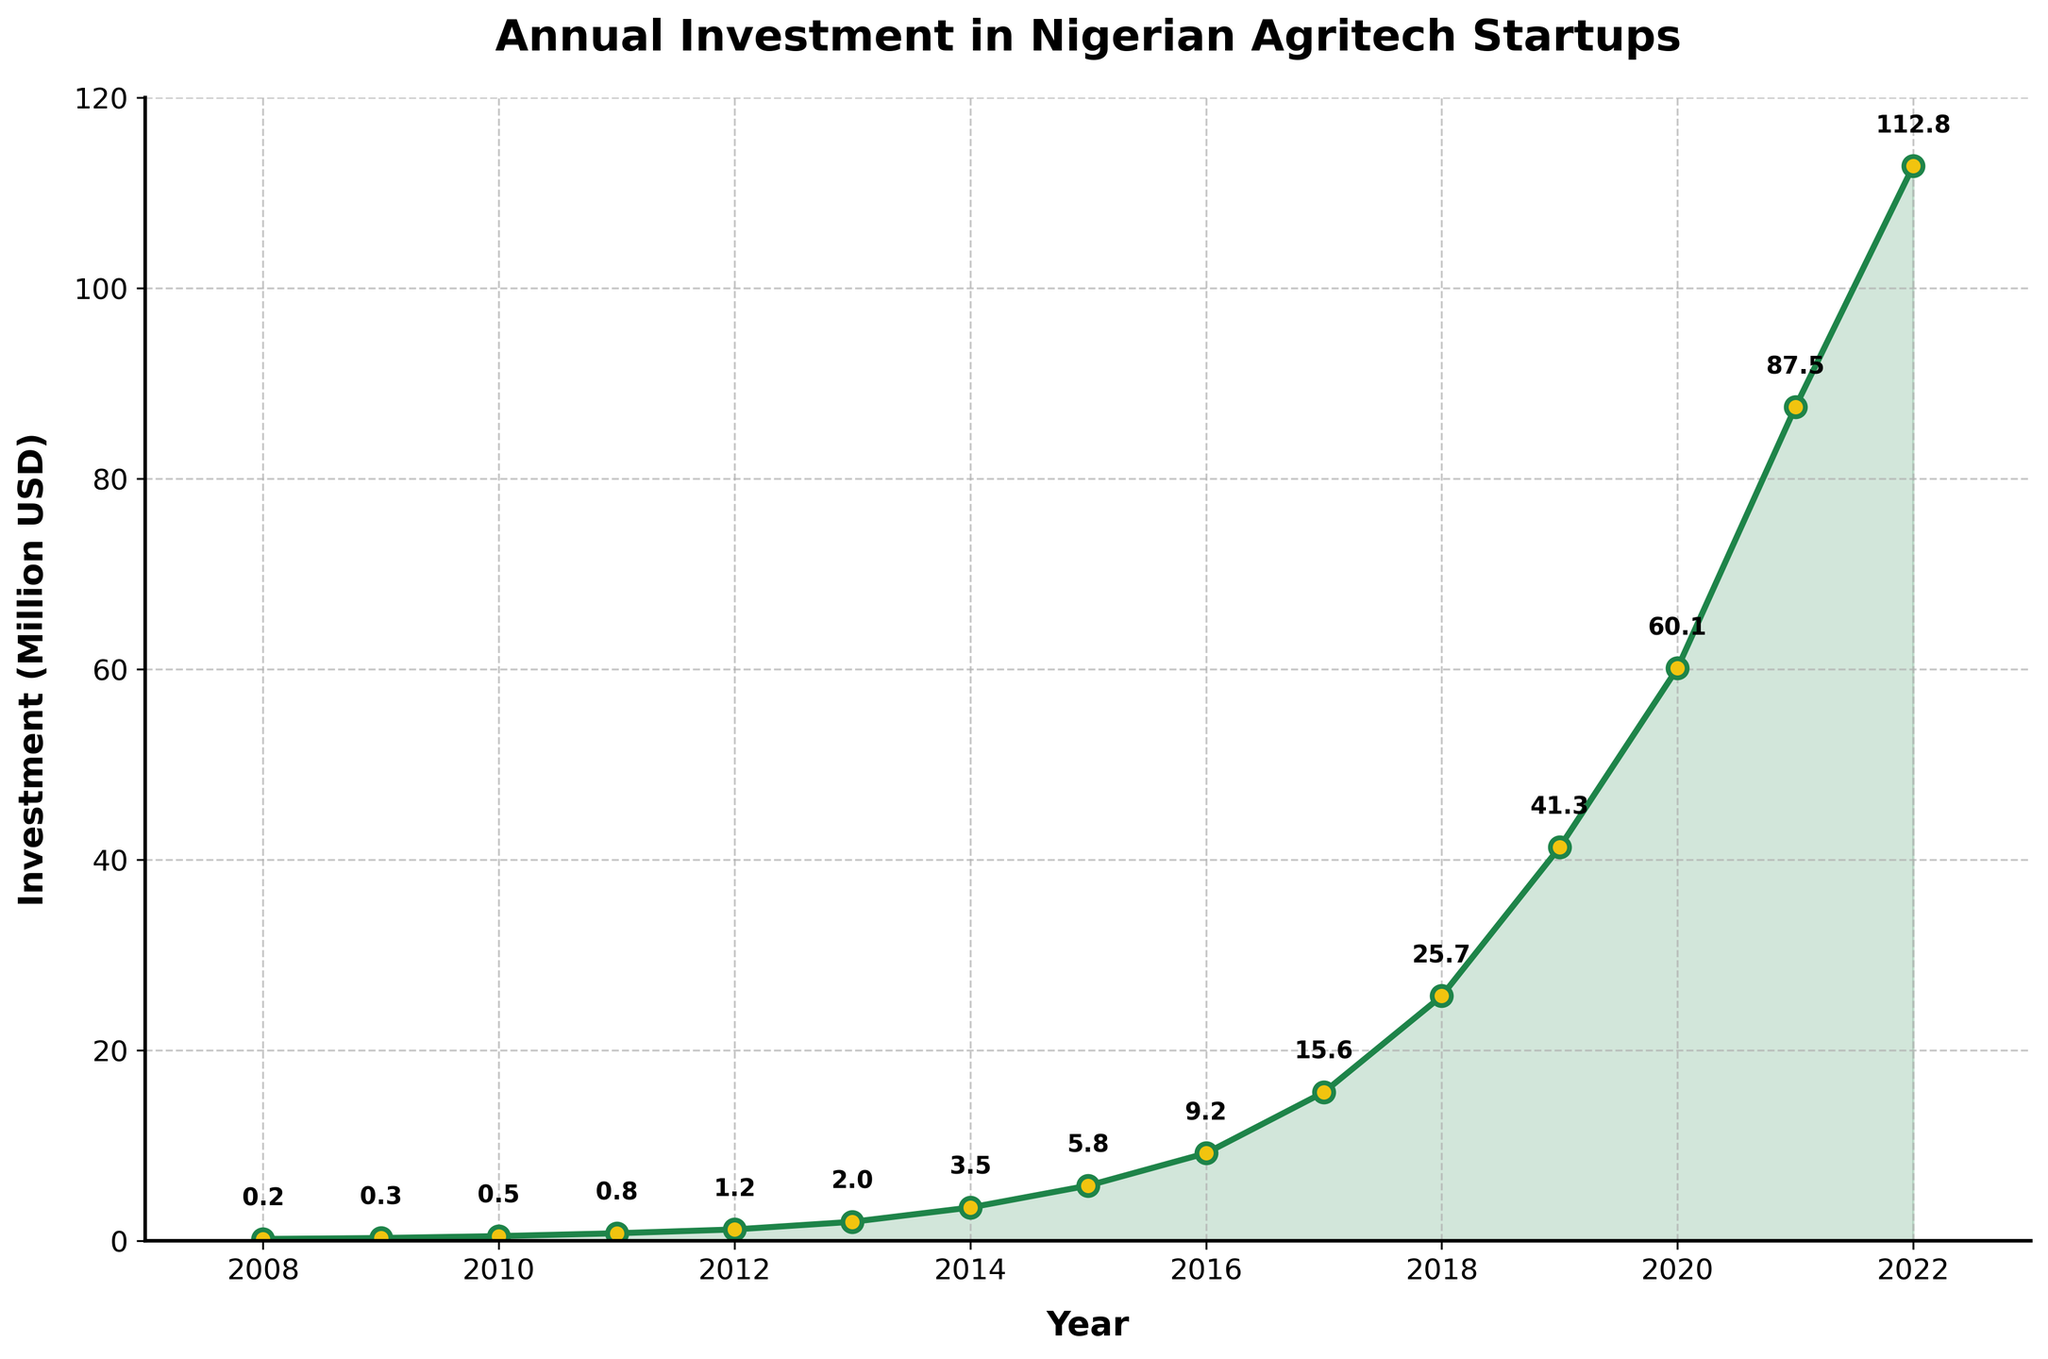What is the approximate increase in annual investment from 2008 to 2022? The annual investment in 2008 was $0.2 million, and by 2022 it had increased to $112.8 million. The approximate increase would be $112.8 million - $0.2 million = $112.6 million
Answer: $112.6 million How does the investment in 2020 compare to the investment in 2015? The investment in 2015 was $5.8 million, while in 2020, it was $60.1 million. Therefore, the 2020 investment is significantly higher than the 2015 investment.
Answer: Significantly higher Which year saw the highest increase in investment compared to the previous year? Observing the plotted data, 2021 saw the highest increase in investment compared to 2020. The investment in 2020 was $60.1 million which increased to $87.5 million in 2021, an increase of $27.4 million.
Answer: 2021 Which years experienced a doubling of investment compared to the previous year? We look for years where the investment is at least twice the previous year's investment. The notable observations are from 2014 to 2015 ($3.5 million to $5.8 million) and from 2017 to 2018 ($15.6 million to $25.7 million). However, doubling is best seen from 2013 to 2014 ($2.0 million to $3.5 million) and from 2016 to 2017 ($9.2 million to $15.6 million).
Answer: 2014, 2017 What is the average annual investment over all the years presented? Sum all the investments from 2008 to 2022 and divide by the number of years. The sum is \(0.2+0.3+0.5+0.8+1.2+2.0+3.5+5.8+9.2+15.6+25.7+41.3+60.1+87.5+112.8 = 366.5.\) With 15 years, the average is \( \frac{366.5}{15} \approx 24.43\).
Answer: $24.43 million Which year had the lowest investment? Based on the plot, the year with the lowest investment was 2008 with an investment of $0.2 million.
Answer: 2008 How does the trend of investment look from 2008 to 2022? The trend in the plot shows a consistent and significant increase over the years, starting from $0.2 million in 2008 to $112.8 million in 2022, signifying a strong growth pattern in annual investments in Nigerian agritech startups.
Answer: Steady and significant growth In which year did the investment surpass $10 million for the first time? Observing the plot, the investment first surpassed $10 million in the year 2017, where the investment was $15.6 million.
Answer: 2017 What percentage increase in investment was observed from 2019 to 2020? Investment in 2019 was $41.3 million, and in 2020 it was $60.1 million. The percentage increase is \(\frac{60.1 - 41.3}{41.3} \times 100 \approx 45.53\%\)
Answer: 45.53% What color is used to mark the line and points representing annual investments? The plot uses a green color to mark the line and the points representing annual investments. Additionally, the markers have yellow faces with green edges.
Answer: Green 